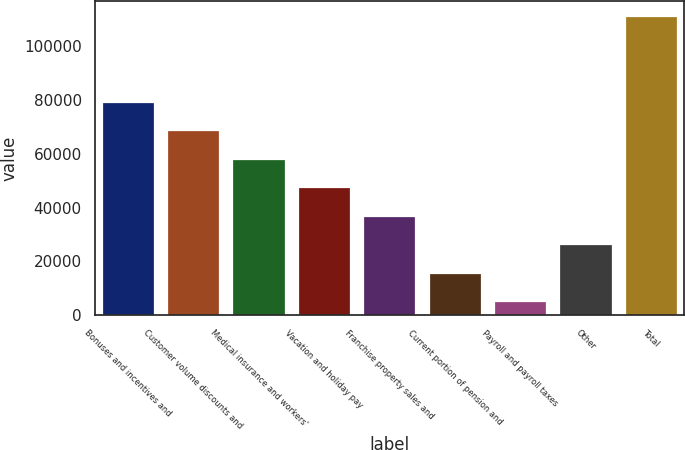Convert chart. <chart><loc_0><loc_0><loc_500><loc_500><bar_chart><fcel>Bonuses and incentives and<fcel>Customer volume discounts and<fcel>Medical insurance and workers'<fcel>Vacation and holiday pay<fcel>Franchise property sales and<fcel>Current portion of pension and<fcel>Payroll and payroll taxes<fcel>Other<fcel>Total<nl><fcel>79387<fcel>68780<fcel>58173<fcel>47566<fcel>36959<fcel>15745<fcel>5138<fcel>26352<fcel>111208<nl></chart> 